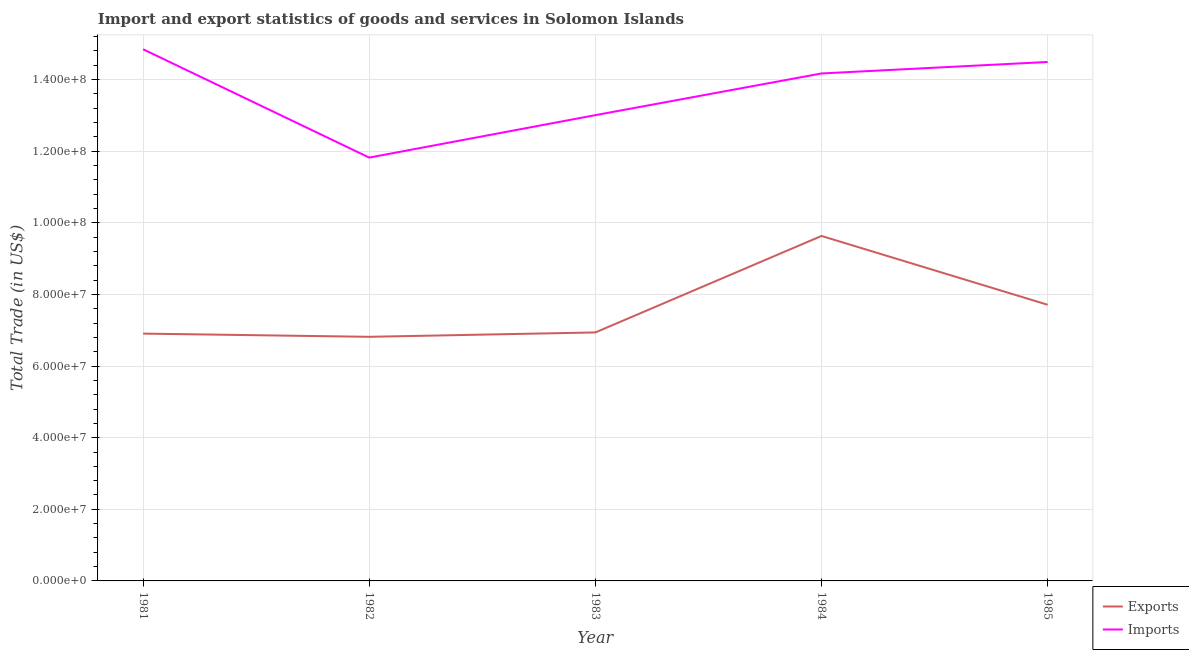How many different coloured lines are there?
Your response must be concise. 2. Does the line corresponding to imports of goods and services intersect with the line corresponding to export of goods and services?
Your answer should be compact. No. Is the number of lines equal to the number of legend labels?
Ensure brevity in your answer.  Yes. What is the imports of goods and services in 1984?
Keep it short and to the point. 1.42e+08. Across all years, what is the maximum export of goods and services?
Your answer should be compact. 9.63e+07. Across all years, what is the minimum imports of goods and services?
Provide a short and direct response. 1.18e+08. What is the total imports of goods and services in the graph?
Offer a very short reply. 6.83e+08. What is the difference between the imports of goods and services in 1981 and that in 1984?
Your answer should be very brief. 6.76e+06. What is the difference between the imports of goods and services in 1983 and the export of goods and services in 1985?
Your answer should be very brief. 5.30e+07. What is the average imports of goods and services per year?
Your answer should be very brief. 1.37e+08. In the year 1981, what is the difference between the export of goods and services and imports of goods and services?
Offer a terse response. -7.94e+07. In how many years, is the export of goods and services greater than 144000000 US$?
Give a very brief answer. 0. What is the ratio of the export of goods and services in 1982 to that in 1985?
Your answer should be very brief. 0.88. Is the imports of goods and services in 1981 less than that in 1984?
Make the answer very short. No. What is the difference between the highest and the second highest export of goods and services?
Make the answer very short. 1.92e+07. What is the difference between the highest and the lowest imports of goods and services?
Make the answer very short. 3.03e+07. In how many years, is the imports of goods and services greater than the average imports of goods and services taken over all years?
Your answer should be very brief. 3. Is the sum of the export of goods and services in 1983 and 1984 greater than the maximum imports of goods and services across all years?
Provide a succinct answer. Yes. Does the export of goods and services monotonically increase over the years?
Your answer should be compact. No. Is the imports of goods and services strictly greater than the export of goods and services over the years?
Your answer should be compact. Yes. Are the values on the major ticks of Y-axis written in scientific E-notation?
Your answer should be very brief. Yes. Does the graph contain any zero values?
Give a very brief answer. No. Where does the legend appear in the graph?
Provide a short and direct response. Bottom right. What is the title of the graph?
Offer a very short reply. Import and export statistics of goods and services in Solomon Islands. What is the label or title of the Y-axis?
Keep it short and to the point. Total Trade (in US$). What is the Total Trade (in US$) of Exports in 1981?
Provide a succinct answer. 6.91e+07. What is the Total Trade (in US$) of Imports in 1981?
Your answer should be compact. 1.48e+08. What is the Total Trade (in US$) in Exports in 1982?
Provide a short and direct response. 6.82e+07. What is the Total Trade (in US$) of Imports in 1982?
Provide a short and direct response. 1.18e+08. What is the Total Trade (in US$) of Exports in 1983?
Your response must be concise. 6.94e+07. What is the Total Trade (in US$) in Imports in 1983?
Offer a terse response. 1.30e+08. What is the Total Trade (in US$) of Exports in 1984?
Provide a short and direct response. 9.63e+07. What is the Total Trade (in US$) of Imports in 1984?
Offer a terse response. 1.42e+08. What is the Total Trade (in US$) of Exports in 1985?
Your answer should be very brief. 7.71e+07. What is the Total Trade (in US$) in Imports in 1985?
Offer a very short reply. 1.45e+08. Across all years, what is the maximum Total Trade (in US$) in Exports?
Your answer should be compact. 9.63e+07. Across all years, what is the maximum Total Trade (in US$) in Imports?
Your answer should be compact. 1.48e+08. Across all years, what is the minimum Total Trade (in US$) of Exports?
Make the answer very short. 6.82e+07. Across all years, what is the minimum Total Trade (in US$) in Imports?
Offer a very short reply. 1.18e+08. What is the total Total Trade (in US$) in Exports in the graph?
Make the answer very short. 3.80e+08. What is the total Total Trade (in US$) of Imports in the graph?
Provide a succinct answer. 6.83e+08. What is the difference between the Total Trade (in US$) of Exports in 1981 and that in 1982?
Ensure brevity in your answer.  8.94e+05. What is the difference between the Total Trade (in US$) of Imports in 1981 and that in 1982?
Your answer should be very brief. 3.03e+07. What is the difference between the Total Trade (in US$) of Exports in 1981 and that in 1983?
Ensure brevity in your answer.  -3.24e+05. What is the difference between the Total Trade (in US$) of Imports in 1981 and that in 1983?
Provide a succinct answer. 1.84e+07. What is the difference between the Total Trade (in US$) of Exports in 1981 and that in 1984?
Offer a terse response. -2.73e+07. What is the difference between the Total Trade (in US$) of Imports in 1981 and that in 1984?
Your answer should be compact. 6.76e+06. What is the difference between the Total Trade (in US$) of Exports in 1981 and that in 1985?
Give a very brief answer. -8.06e+06. What is the difference between the Total Trade (in US$) of Imports in 1981 and that in 1985?
Make the answer very short. 3.55e+06. What is the difference between the Total Trade (in US$) of Exports in 1982 and that in 1983?
Offer a terse response. -1.22e+06. What is the difference between the Total Trade (in US$) in Imports in 1982 and that in 1983?
Provide a short and direct response. -1.19e+07. What is the difference between the Total Trade (in US$) in Exports in 1982 and that in 1984?
Your response must be concise. -2.82e+07. What is the difference between the Total Trade (in US$) in Imports in 1982 and that in 1984?
Your answer should be compact. -2.35e+07. What is the difference between the Total Trade (in US$) in Exports in 1982 and that in 1985?
Keep it short and to the point. -8.95e+06. What is the difference between the Total Trade (in US$) in Imports in 1982 and that in 1985?
Your response must be concise. -2.67e+07. What is the difference between the Total Trade (in US$) of Exports in 1983 and that in 1984?
Your response must be concise. -2.69e+07. What is the difference between the Total Trade (in US$) of Imports in 1983 and that in 1984?
Ensure brevity in your answer.  -1.16e+07. What is the difference between the Total Trade (in US$) of Exports in 1983 and that in 1985?
Your answer should be compact. -7.73e+06. What is the difference between the Total Trade (in US$) of Imports in 1983 and that in 1985?
Give a very brief answer. -1.49e+07. What is the difference between the Total Trade (in US$) of Exports in 1984 and that in 1985?
Your answer should be compact. 1.92e+07. What is the difference between the Total Trade (in US$) of Imports in 1984 and that in 1985?
Your response must be concise. -3.21e+06. What is the difference between the Total Trade (in US$) in Exports in 1981 and the Total Trade (in US$) in Imports in 1982?
Your answer should be very brief. -4.92e+07. What is the difference between the Total Trade (in US$) in Exports in 1981 and the Total Trade (in US$) in Imports in 1983?
Your response must be concise. -6.10e+07. What is the difference between the Total Trade (in US$) in Exports in 1981 and the Total Trade (in US$) in Imports in 1984?
Make the answer very short. -7.26e+07. What is the difference between the Total Trade (in US$) in Exports in 1981 and the Total Trade (in US$) in Imports in 1985?
Provide a succinct answer. -7.59e+07. What is the difference between the Total Trade (in US$) of Exports in 1982 and the Total Trade (in US$) of Imports in 1983?
Your answer should be compact. -6.19e+07. What is the difference between the Total Trade (in US$) of Exports in 1982 and the Total Trade (in US$) of Imports in 1984?
Your answer should be compact. -7.35e+07. What is the difference between the Total Trade (in US$) of Exports in 1982 and the Total Trade (in US$) of Imports in 1985?
Keep it short and to the point. -7.68e+07. What is the difference between the Total Trade (in US$) of Exports in 1983 and the Total Trade (in US$) of Imports in 1984?
Keep it short and to the point. -7.23e+07. What is the difference between the Total Trade (in US$) of Exports in 1983 and the Total Trade (in US$) of Imports in 1985?
Provide a short and direct response. -7.55e+07. What is the difference between the Total Trade (in US$) in Exports in 1984 and the Total Trade (in US$) in Imports in 1985?
Make the answer very short. -4.86e+07. What is the average Total Trade (in US$) in Exports per year?
Your answer should be compact. 7.60e+07. What is the average Total Trade (in US$) of Imports per year?
Make the answer very short. 1.37e+08. In the year 1981, what is the difference between the Total Trade (in US$) of Exports and Total Trade (in US$) of Imports?
Make the answer very short. -7.94e+07. In the year 1982, what is the difference between the Total Trade (in US$) of Exports and Total Trade (in US$) of Imports?
Your response must be concise. -5.00e+07. In the year 1983, what is the difference between the Total Trade (in US$) of Exports and Total Trade (in US$) of Imports?
Offer a very short reply. -6.07e+07. In the year 1984, what is the difference between the Total Trade (in US$) of Exports and Total Trade (in US$) of Imports?
Your response must be concise. -4.54e+07. In the year 1985, what is the difference between the Total Trade (in US$) of Exports and Total Trade (in US$) of Imports?
Keep it short and to the point. -6.78e+07. What is the ratio of the Total Trade (in US$) in Exports in 1981 to that in 1982?
Your answer should be compact. 1.01. What is the ratio of the Total Trade (in US$) in Imports in 1981 to that in 1982?
Provide a short and direct response. 1.26. What is the ratio of the Total Trade (in US$) of Imports in 1981 to that in 1983?
Your answer should be compact. 1.14. What is the ratio of the Total Trade (in US$) of Exports in 1981 to that in 1984?
Offer a very short reply. 0.72. What is the ratio of the Total Trade (in US$) in Imports in 1981 to that in 1984?
Provide a succinct answer. 1.05. What is the ratio of the Total Trade (in US$) in Exports in 1981 to that in 1985?
Your answer should be compact. 0.9. What is the ratio of the Total Trade (in US$) of Imports in 1981 to that in 1985?
Give a very brief answer. 1.02. What is the ratio of the Total Trade (in US$) in Exports in 1982 to that in 1983?
Give a very brief answer. 0.98. What is the ratio of the Total Trade (in US$) in Imports in 1982 to that in 1983?
Your response must be concise. 0.91. What is the ratio of the Total Trade (in US$) in Exports in 1982 to that in 1984?
Your response must be concise. 0.71. What is the ratio of the Total Trade (in US$) of Imports in 1982 to that in 1984?
Your answer should be compact. 0.83. What is the ratio of the Total Trade (in US$) in Exports in 1982 to that in 1985?
Keep it short and to the point. 0.88. What is the ratio of the Total Trade (in US$) in Imports in 1982 to that in 1985?
Your answer should be very brief. 0.82. What is the ratio of the Total Trade (in US$) of Exports in 1983 to that in 1984?
Offer a terse response. 0.72. What is the ratio of the Total Trade (in US$) in Imports in 1983 to that in 1984?
Offer a very short reply. 0.92. What is the ratio of the Total Trade (in US$) in Exports in 1983 to that in 1985?
Your answer should be compact. 0.9. What is the ratio of the Total Trade (in US$) in Imports in 1983 to that in 1985?
Your answer should be very brief. 0.9. What is the ratio of the Total Trade (in US$) of Exports in 1984 to that in 1985?
Give a very brief answer. 1.25. What is the ratio of the Total Trade (in US$) in Imports in 1984 to that in 1985?
Provide a short and direct response. 0.98. What is the difference between the highest and the second highest Total Trade (in US$) in Exports?
Offer a very short reply. 1.92e+07. What is the difference between the highest and the second highest Total Trade (in US$) in Imports?
Make the answer very short. 3.55e+06. What is the difference between the highest and the lowest Total Trade (in US$) of Exports?
Your answer should be very brief. 2.82e+07. What is the difference between the highest and the lowest Total Trade (in US$) in Imports?
Provide a succinct answer. 3.03e+07. 